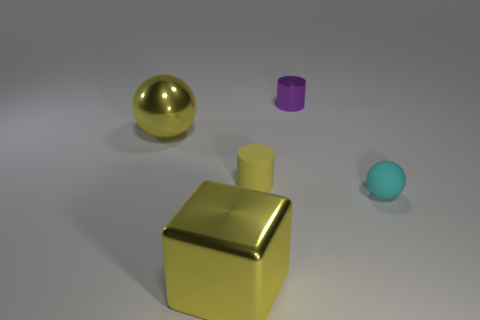Is the material of the tiny yellow cylinder the same as the purple thing?
Provide a short and direct response. No. How many tiny yellow things are the same shape as the small cyan object?
Make the answer very short. 0. Are there the same number of metal objects that are behind the large yellow metal sphere and purple shiny cylinders?
Provide a succinct answer. Yes. The metal thing that is the same size as the yellow shiny block is what color?
Provide a short and direct response. Yellow. Is there a tiny yellow matte object that has the same shape as the small metal thing?
Keep it short and to the point. Yes. What is the tiny yellow thing that is behind the sphere that is to the right of the shiny thing right of the large yellow metallic block made of?
Your answer should be compact. Rubber. What number of other things are the same size as the shiny block?
Keep it short and to the point. 1. The small rubber ball has what color?
Provide a short and direct response. Cyan. How many metallic things are either large red cylinders or small yellow cylinders?
Make the answer very short. 0. There is a shiny thing right of the large yellow thing that is on the right side of the large yellow object behind the cyan object; what size is it?
Your answer should be compact. Small. 